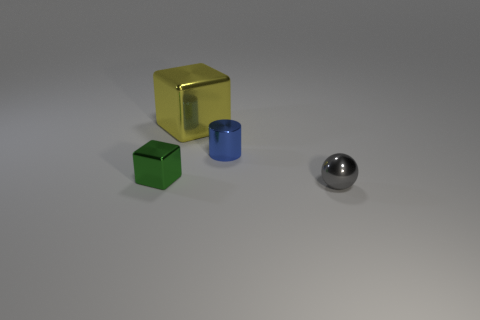Add 3 large cubes. How many objects exist? 7 Subtract all gray balls. How many green cylinders are left? 0 Subtract all tiny shiny cylinders. Subtract all small gray shiny objects. How many objects are left? 2 Add 1 small cubes. How many small cubes are left? 2 Add 2 small blue metallic cylinders. How many small blue metallic cylinders exist? 3 Subtract 1 green blocks. How many objects are left? 3 Subtract all cylinders. How many objects are left? 3 Subtract 1 blocks. How many blocks are left? 1 Subtract all red cubes. Subtract all brown cylinders. How many cubes are left? 2 